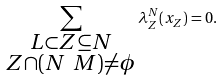<formula> <loc_0><loc_0><loc_500><loc_500>\sum _ { \substack { L \subset Z \subseteq N \\ Z \cap ( N \ M ) \neq \phi } } \lambda _ { Z } ^ { N } ( x _ { Z } ) = 0 .</formula> 